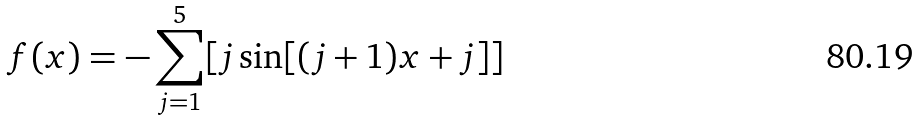Convert formula to latex. <formula><loc_0><loc_0><loc_500><loc_500>f ( x ) = - \sum _ { j = 1 } ^ { 5 } [ j \sin [ ( j + 1 ) x + j ] ]</formula> 